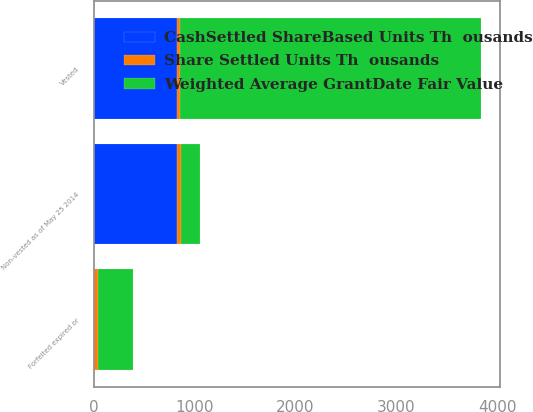Convert chart to OTSL. <chart><loc_0><loc_0><loc_500><loc_500><stacked_bar_chart><ecel><fcel>Non-vested as of May 25 2014<fcel>Vested<fcel>Forfeited expired or<nl><fcel>Weighted Average GrantDate Fair Value<fcel>192.115<fcel>2978.7<fcel>338.1<nl><fcel>Share Settled Units Th  ousands<fcel>40.81<fcel>35.19<fcel>46.13<nl><fcel>CashSettled ShareBased Units Th  ousands<fcel>822.8<fcel>822.1<fcel>0.7<nl></chart> 